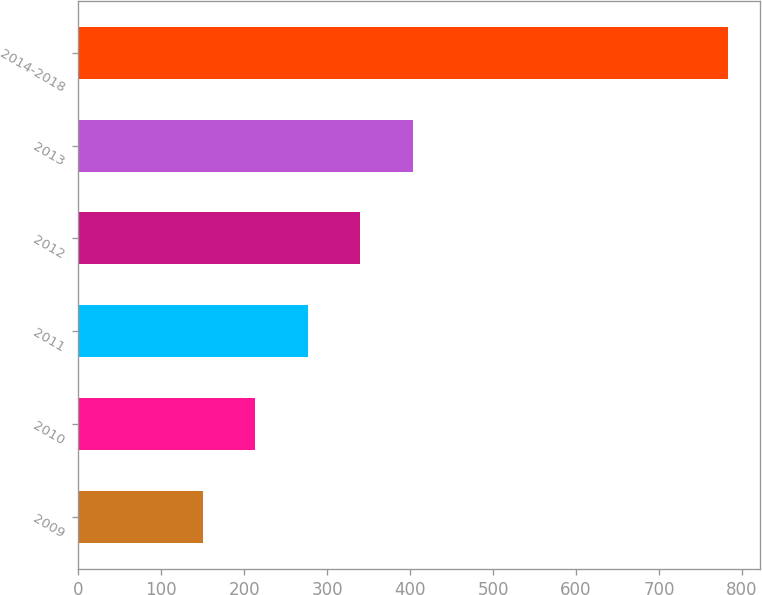<chart> <loc_0><loc_0><loc_500><loc_500><bar_chart><fcel>2009<fcel>2010<fcel>2011<fcel>2012<fcel>2013<fcel>2014-2018<nl><fcel>150<fcel>213.3<fcel>276.6<fcel>339.9<fcel>403.2<fcel>783<nl></chart> 